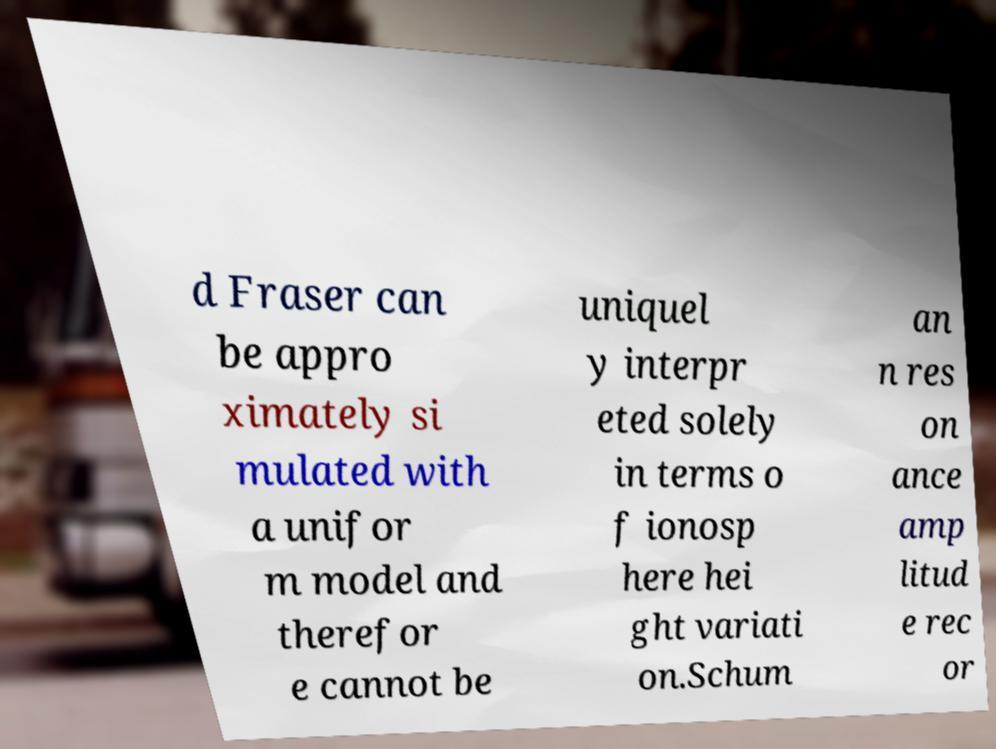Please identify and transcribe the text found in this image. d Fraser can be appro ximately si mulated with a unifor m model and therefor e cannot be uniquel y interpr eted solely in terms o f ionosp here hei ght variati on.Schum an n res on ance amp litud e rec or 